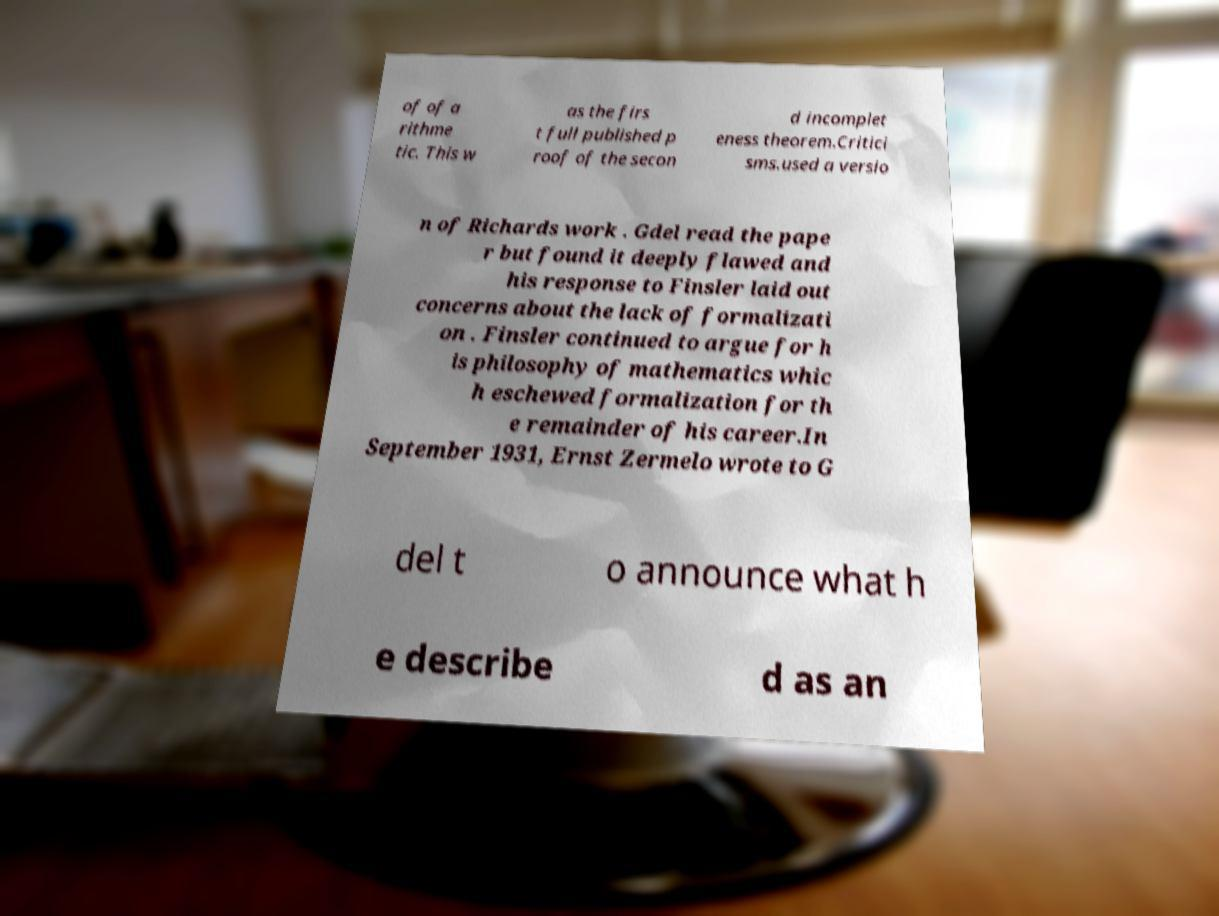Could you extract and type out the text from this image? of of a rithme tic. This w as the firs t full published p roof of the secon d incomplet eness theorem.Critici sms.used a versio n of Richards work . Gdel read the pape r but found it deeply flawed and his response to Finsler laid out concerns about the lack of formalizati on . Finsler continued to argue for h is philosophy of mathematics whic h eschewed formalization for th e remainder of his career.In September 1931, Ernst Zermelo wrote to G del t o announce what h e describe d as an 